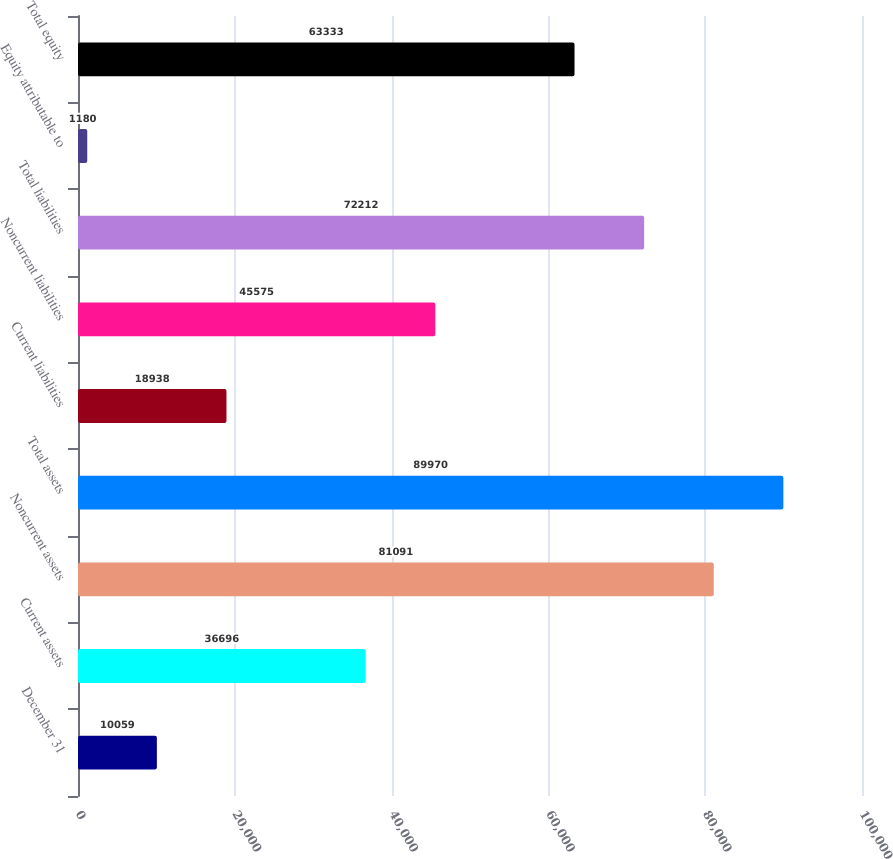Convert chart. <chart><loc_0><loc_0><loc_500><loc_500><bar_chart><fcel>December 31<fcel>Current assets<fcel>Noncurrent assets<fcel>Total assets<fcel>Current liabilities<fcel>Noncurrent liabilities<fcel>Total liabilities<fcel>Equity attributable to<fcel>Total equity<nl><fcel>10059<fcel>36696<fcel>81091<fcel>89970<fcel>18938<fcel>45575<fcel>72212<fcel>1180<fcel>63333<nl></chart> 